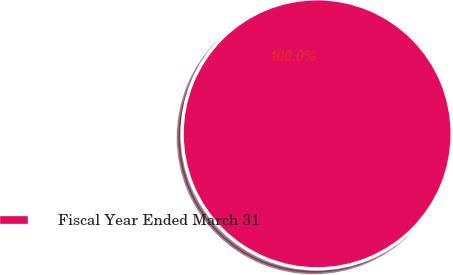Convert chart to OTSL. <chart><loc_0><loc_0><loc_500><loc_500><pie_chart><fcel>Fiscal Year Ended March 31<nl><fcel>100.0%<nl></chart> 